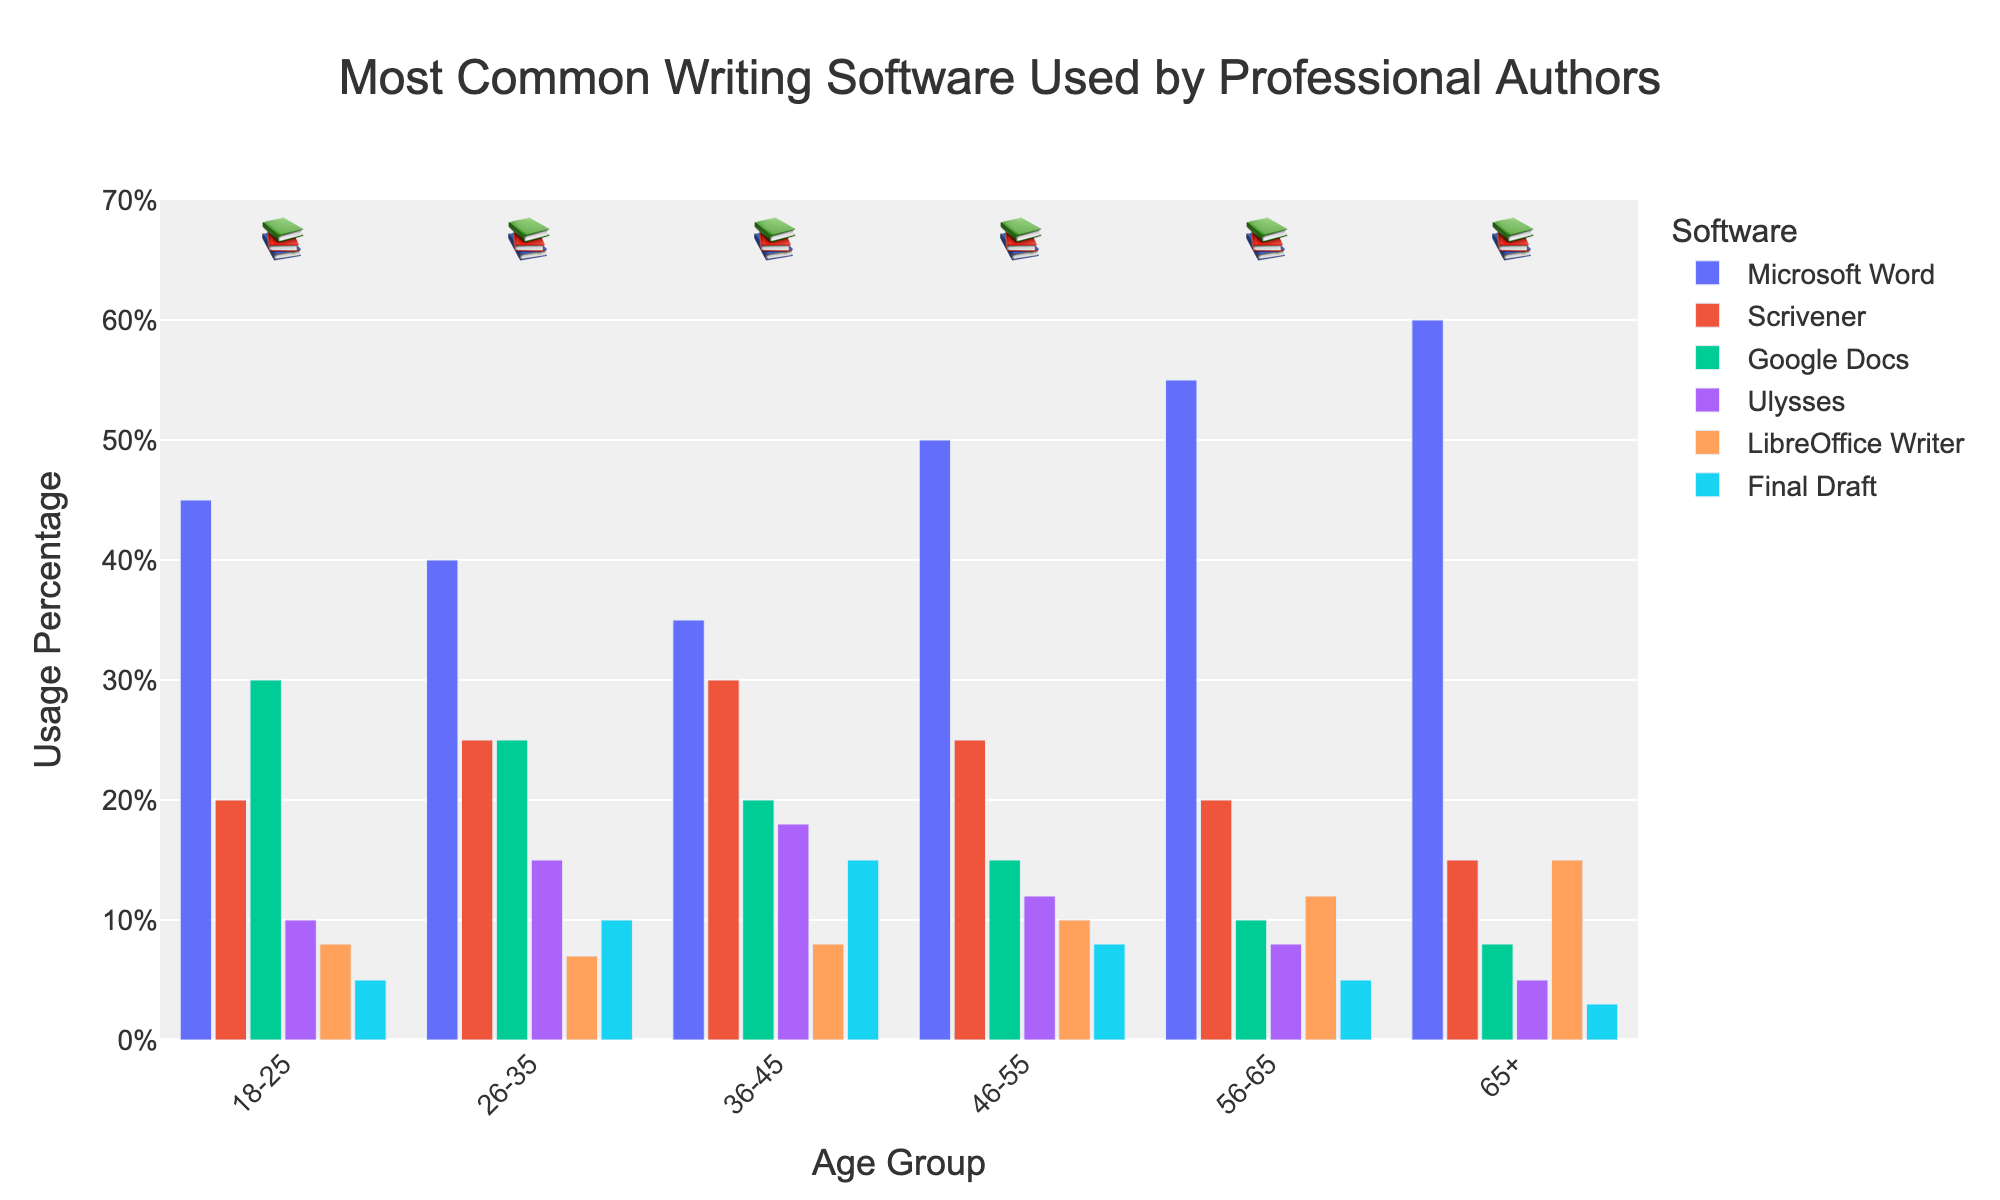What is the most commonly used writing software among authors aged 65+? The chart shows that Microsoft Word is consistently the tallest bar across all age groups, including the 65+ age group.
Answer: Microsoft Word Which age group has the highest usage of Scrivener? The 36-45 age group has the tallest bar for Scrivener usage among all age groups.
Answer: 36-45 How does the usage of Google Docs compare between the youngest (18-25) and oldest (65+) age groups? By comparing the heights of the bars for Google Docs in the 18-25 and 65+ age groups, it is clear that the bar is higher for the 18-25 group.
Answer: Google Docs usage is higher in the 18-25 age group What's the combined percentage usage of Microsoft Word and Scrivener for the 26-35 age group? For the 26-35 age group, the usage of Microsoft Word is 40% and Scrivener is 25%. Adding these together results in 40 + 25 = 65%.
Answer: 65% Which writing software shows the least variation in usage across the different age groups? By observing the bars' heights, Ulysses shows relatively small changes across the different age groups compared to other software.
Answer: Ulysses Is there any age group where LibreOffice Writer is more popular than Google Docs? For each age group bar comparison, LibreOffice Writer always has a lower height than Google Docs.
Answer: No What is the average usage percentage of Final Draft across all age groups? Adding Final Draft usage across age groups: 5+10+15+8+5+3 = 46, there are 6 age groups, so the average is 46/6 ≈ 7.67%.
Answer: ~7.67% Does any age group show a preference for Final Draft over Scrivener? For all age groups, the bar for Final Draft is always shorter than the bar for Scrivener.
Answer: No In the 46-55 age group, which software is the most and least popular? In the 46-55 age group, the tallest bar is for Microsoft Word, and the shortest bar is for Final Draft.
Answer: Microsoft Word (most), Final Draft (least) 